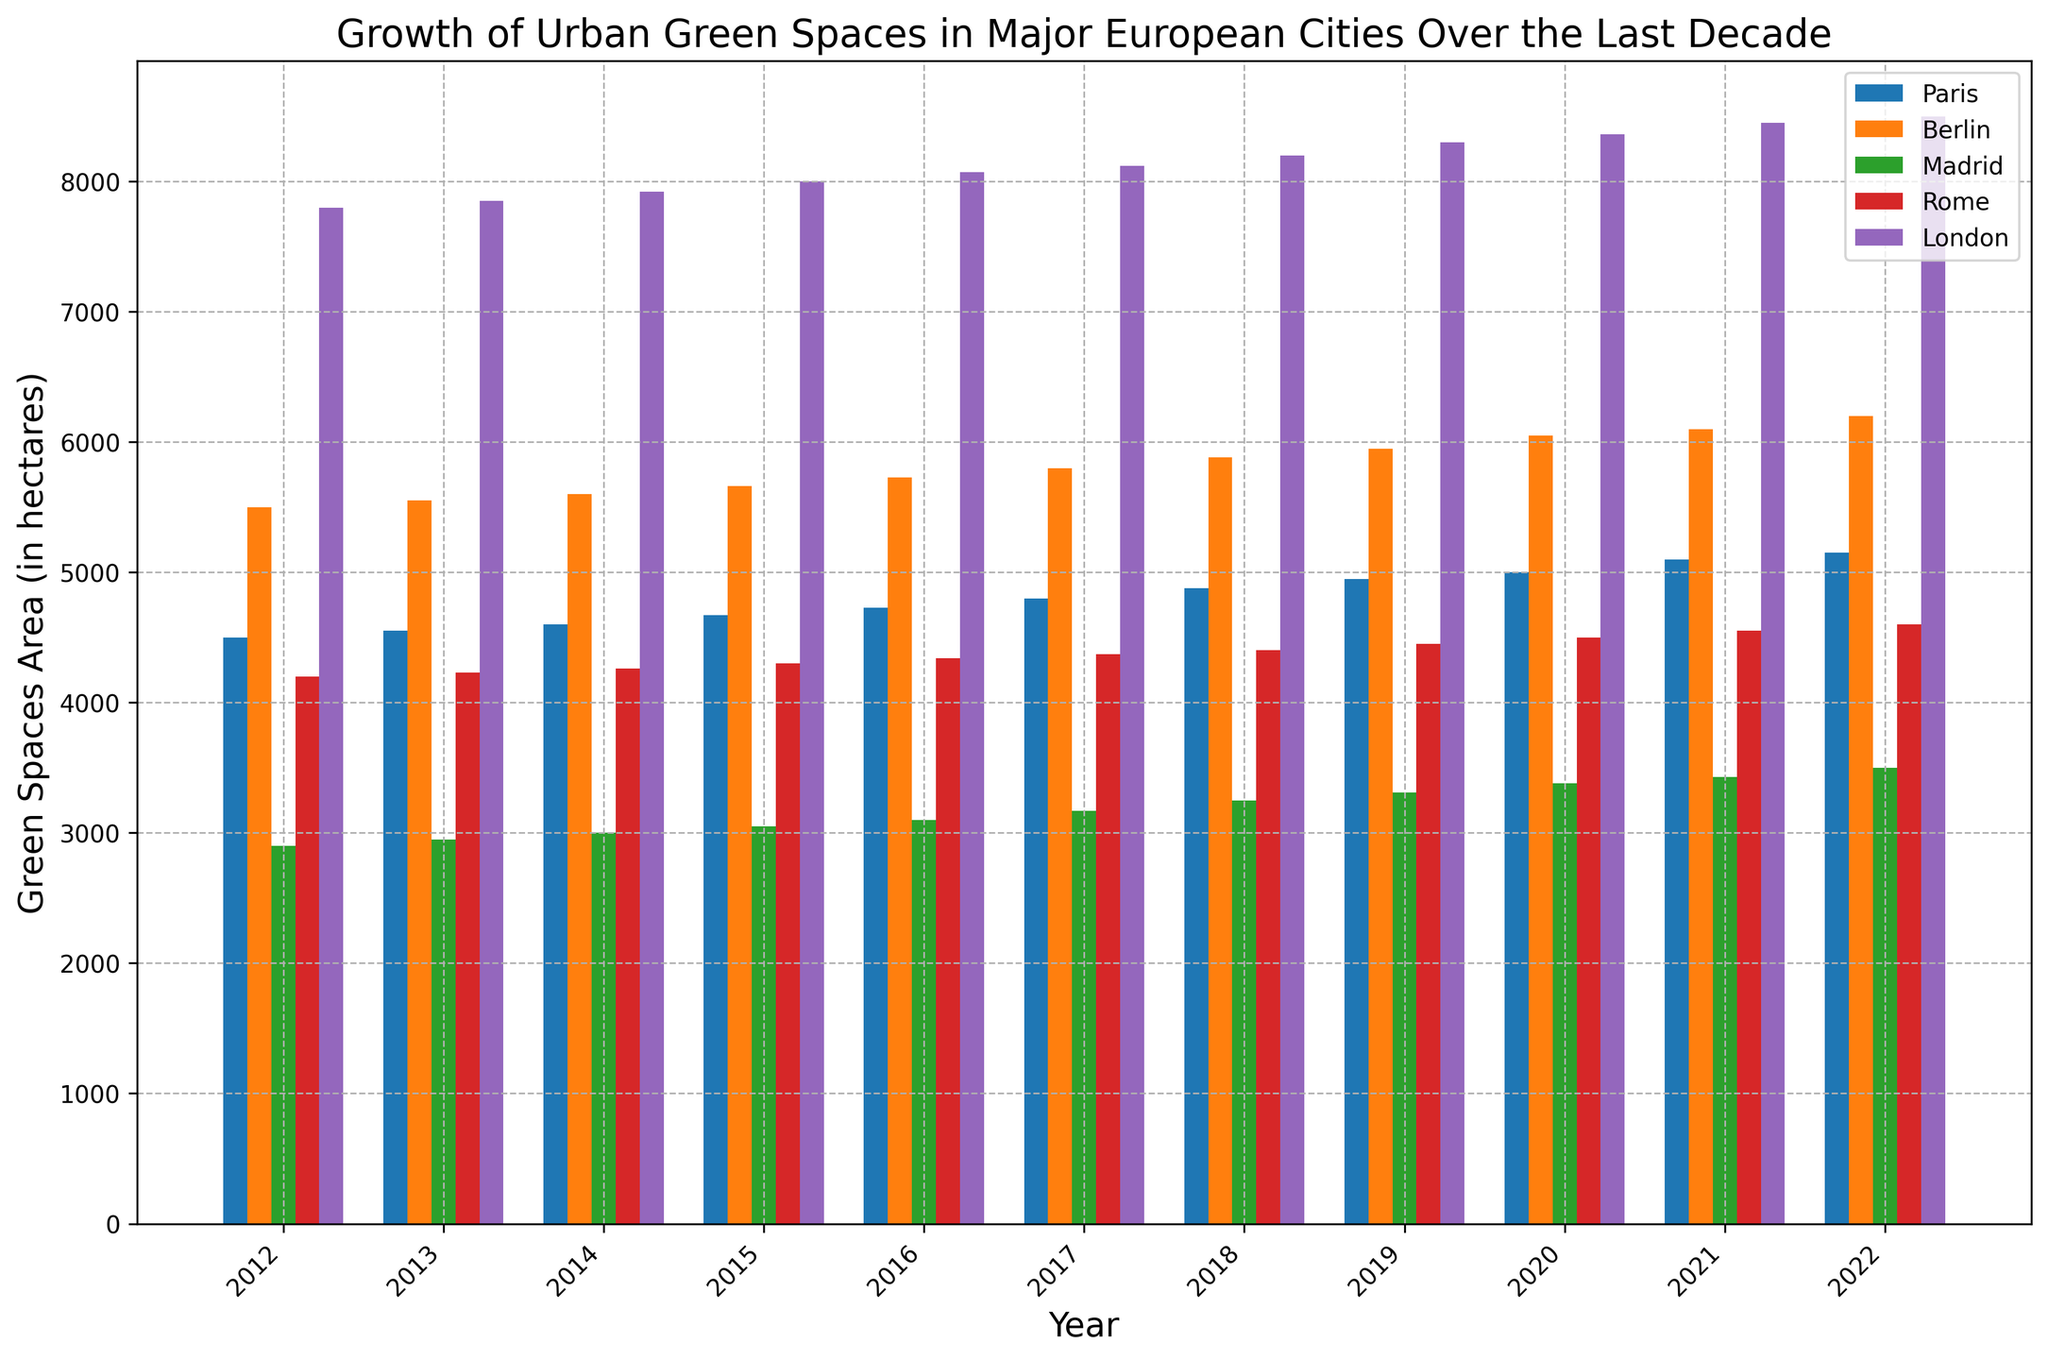Which city had the highest green space area in 2022? By looking at the height of the bars for the year 2022, the city with the highest green space area is London as it has the tallest bar.
Answer: London Which city had the smallest increase in green spaces from 2012 to 2022? Calculate the difference in green space areas between 2012 and 2022 for each city and compare. Paris: 650, Berlin: 700, Madrid: 600, Rome: 400, London: 700. Rome has the smallest increase of 400 hectares.
Answer: Rome Between Paris and Madrid, which city had more urban green space in 2015? Compare the heights of the bars for Paris and Madrid in the year 2015. Paris's bar is taller, indicating a greater green space area.
Answer: Paris What is the average green space area of Rome over the decade (2012-2022)? Sum the green space areas for Rome over each year and divide by the number of years: (4200 + 4230 + ... + 4550 + 4600) / 11 = 4368.18 hectares.
Answer: 4368.18 hectares How much did Berlin's green space area grow between 2018 and 2020? Subtract Berlin's green space area in 2018 from that in 2020: 6050 - 5880 = 170 hectares.
Answer: 170 hectares Which city showed a consistent increase in green space area every year? Review all cities' green space areas year-by-year to determine consistency. Each city (Paris, Berlin, Madrid, Rome, and London) shows a consistent increase each year.
Answer: Paris, Berlin, Madrid, Rome, London In what year did London surpass the 8000 hectares mark in green space area? Look at the green space areas for London over the years. London surpassed the 8000 hectares mark in 2015 when its green space area was 8000 hectares.
Answer: 2015 By how much did green spaces in Madrid grow from 2017 to 2022? Find the difference in green spaces for Madrid between these years: 3500 - 3170 = 330 hectares.
Answer: 330 hectares 